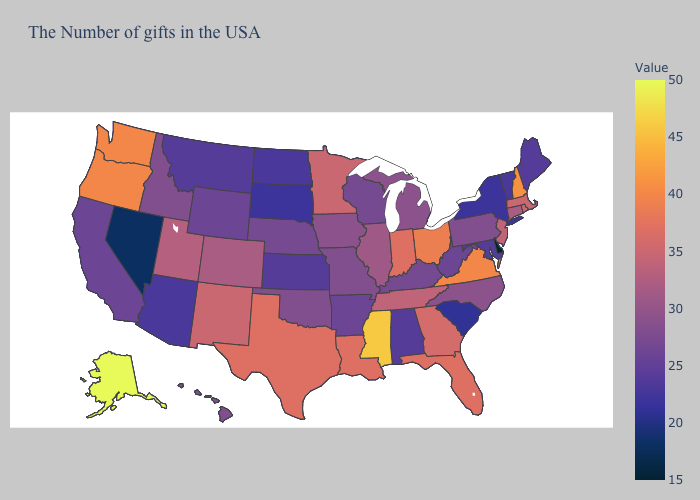Does Delaware have the lowest value in the USA?
Answer briefly. Yes. Which states have the lowest value in the South?
Be succinct. Delaware. Does the map have missing data?
Write a very short answer. No. Which states have the lowest value in the USA?
Write a very short answer. Delaware. Does Rhode Island have a higher value than South Dakota?
Write a very short answer. Yes. Does Kansas have a higher value than Colorado?
Quick response, please. No. 